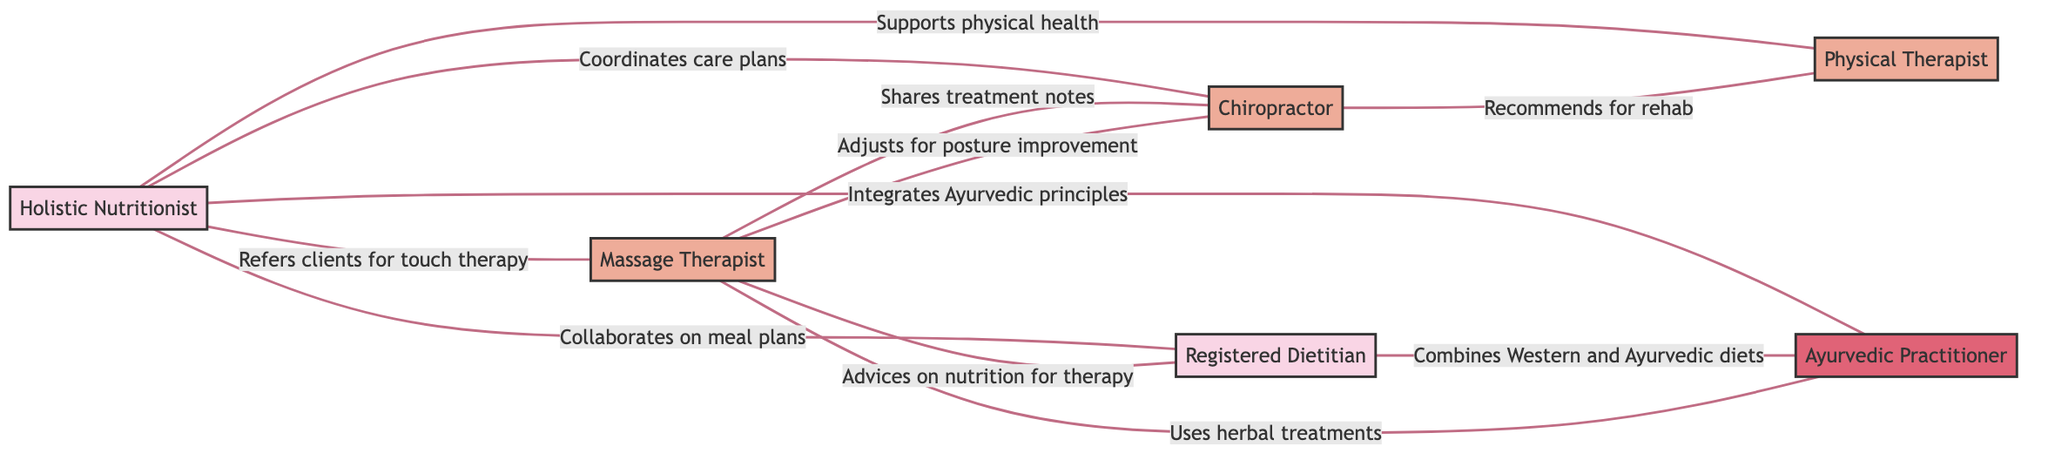What is the total number of nodes in the graph? The graph lists six distinct entities as nodes: Holistic Nutritionist, Massage Therapist, Chiropractor, Registered Dietitian, Ayurvedic Practitioner, and Physical Therapist. Therefore, the total number is six.
Answer: 6 Which node is connected to both the Holistic Nutritionist and the Ayurvedic Practitioner? The Holistic Nutritionist (N1) is directly linked to the Ayurvedic Practitioner (N5) through integration of Ayurvedic principles. Also, N1 is connected to the Physical Therapist (N6). The Ayurvedic Practitioner (N5) is connected only to the Holistic Nutritionist (N1). Thus, no node connects to both; Holistic Nutritionist is only singularly connected to Ayurvedic Practitioner.
Answer: Holistic Nutritionist What type of relationship exists between the Massage Therapist and Chiropractor? The relationship between the Massage Therapist (N2) and the Chiropractor (N3) is labeled as "Shares treatment notes," indicating that they have a collaborative interaction.
Answer: Shares treatment notes How many edges are present in the graph? By counting the links between different nodes, we see there are ten connections (edges) in total: from Holistic Nutritionist to other four nodes, and other mutual connections among Therapy professionals.
Answer: 10 Which two nodes collaborate on meal plans? The interaction labeled "Collaborates on meal plans" connects the Holistic Nutritionist (N1) and the Registered Dietitian (N4). This indicates that these two professionals work together on meal planning for clients.
Answer: Holistic Nutritionist and Registered Dietitian Which node recommends for rehabilitation? The link labeled "Recommends for rehab" identifies the Chiropractor (N3) as the professional providing recommendations for physical rehabilitation, showing their role in recovery processes.
Answer: Chiropractor How many nodes are exclusively therapists? The nodes identified solely as therapists are the Massage Therapist (N2), Chiropractor (N3), and Physical Therapist (N6). Thus, out of the six nodes, three are only therapy practitioners.
Answer: 3 Which connections specifically involve herbal treatments? The link labeled "Uses herbal treatments" indicates the relationship between the Massage Therapist (N2) and the Ayurvedic Practitioner (N5), meaning that this connection highlights the use of herbal treatments in their practices.
Answer: Massage Therapist and Ayurvedic Practitioner 